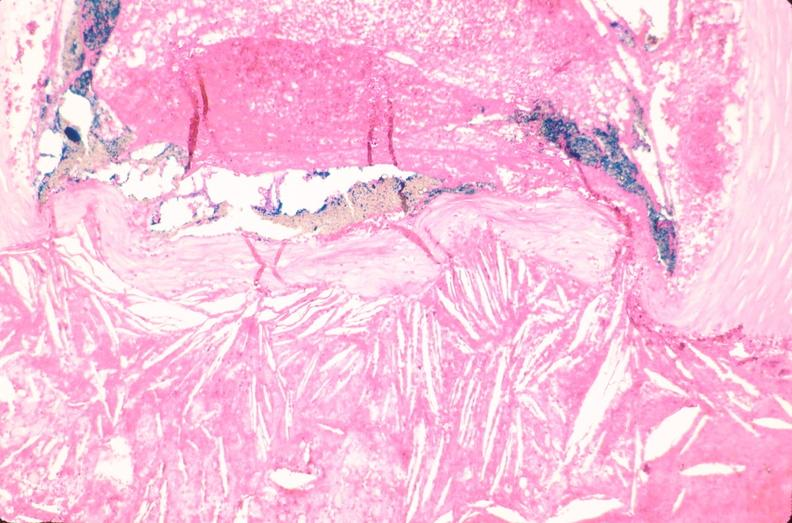s cardiovascular present?
Answer the question using a single word or phrase. Yes 